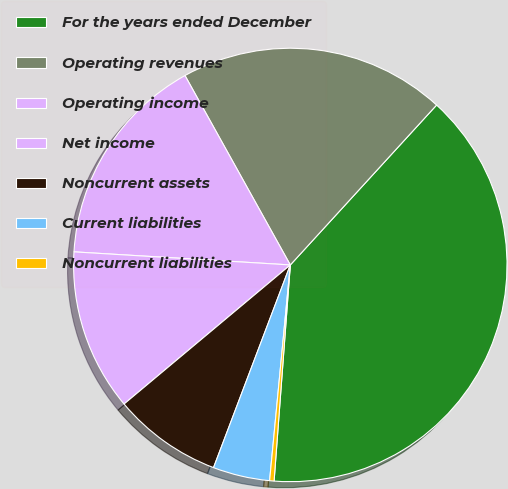Convert chart to OTSL. <chart><loc_0><loc_0><loc_500><loc_500><pie_chart><fcel>For the years ended December<fcel>Operating revenues<fcel>Operating income<fcel>Net income<fcel>Noncurrent assets<fcel>Current liabilities<fcel>Noncurrent liabilities<nl><fcel>39.4%<fcel>19.87%<fcel>15.96%<fcel>12.05%<fcel>8.15%<fcel>4.24%<fcel>0.33%<nl></chart> 